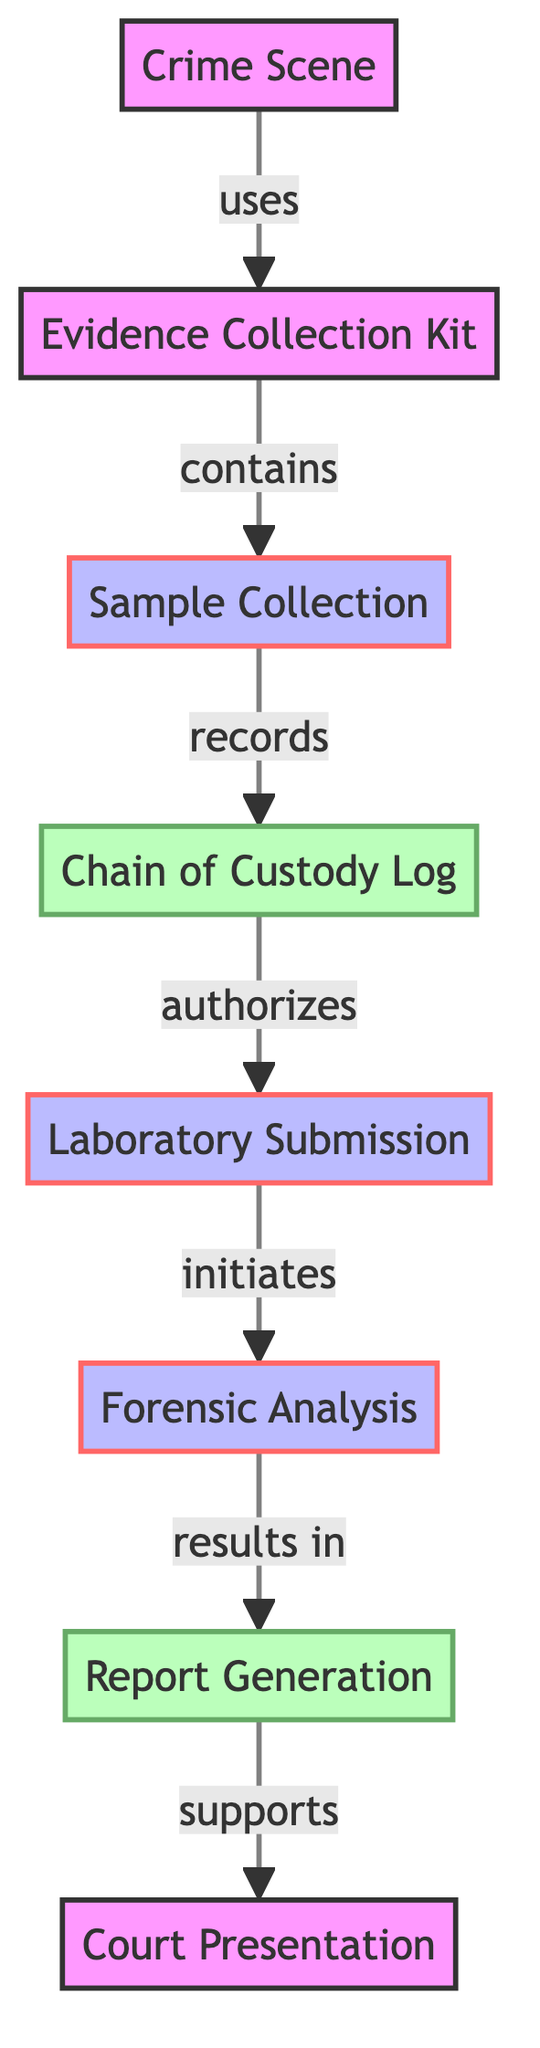What is the starting point of the evidence collection process? The starting point is identified as the "Crime Scene," which is the initial location where chemical evidence is collected, per the diagram.
Answer: Crime Scene How many nodes are present in this directed graph? The directed graph contains eight nodes, representing various steps and elements in the chain of custody for chemical evidence.
Answer: Eight What relationship exists between the "Sample Collection" and the "Chain of Custody Log"? The relationship between these two nodes is that "Sample Collection" "records" the handling of evidence in the "Chain of Custody Log," indicating documentation of the samples collected.
Answer: records Which node follows "Laboratory Submission" in the process sequence? Following the "Laboratory Submission," the next node in the process sequence is "Forensic Analysis," which involves the examination of the submitted samples.
Answer: Forensic Analysis What is authorized by the "Chain of Custody Log"? The "Chain of Custody Log" "authorizes" the "Laboratory Submission," indicating that it provides the necessary documentation for samples to be analyzed in the lab.
Answer: Laboratory Submission What is the final step in the evidence handling process? The final step in the evidence handling process, as outlined in the graph, is "Court Presentation," where the findings from the analysis are presented in a court of law.
Answer: Court Presentation How many edges are there linking the nodes in this diagram? There are seven edges in the diagram, each representing a connection or relationship between different aspects of the evidence handling process.
Answer: Seven Which node is essential for tracking evidence possession? The "Chain of Custody Log" is essential for tracking evidence possession, as it documents the entire handling process of the collected evidence samples.
Answer: Chain of Custody Log What does the "Forensic Analysis" result in? The "Forensic Analysis" results in "Report Generation," which reflects the outcomes of the chemical tests conducted on the submitted samples.
Answer: Report Generation 